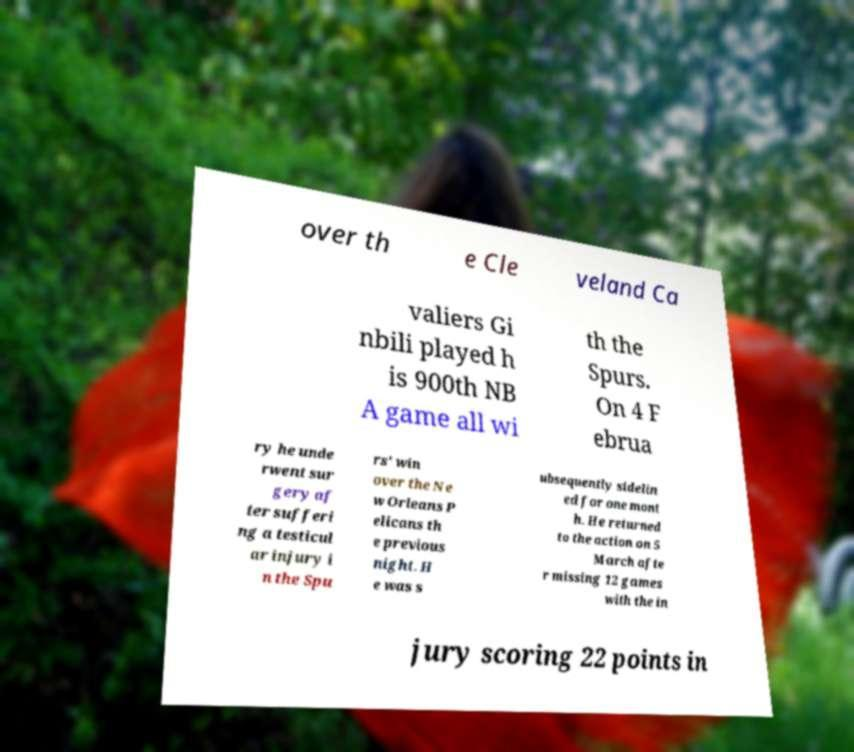Could you extract and type out the text from this image? over th e Cle veland Ca valiers Gi nbili played h is 900th NB A game all wi th the Spurs. On 4 F ebrua ry he unde rwent sur gery af ter sufferi ng a testicul ar injury i n the Spu rs' win over the Ne w Orleans P elicans th e previous night. H e was s ubsequently sidelin ed for one mont h. He returned to the action on 5 March afte r missing 12 games with the in jury scoring 22 points in 